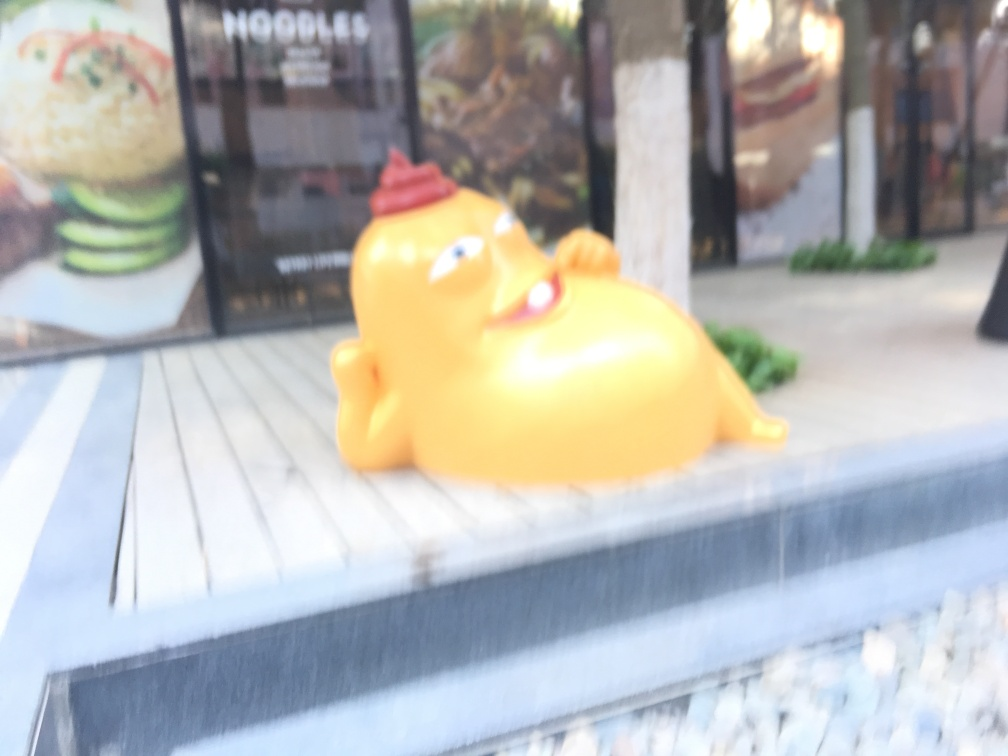How is the texture of the image?
A. Blurry.
B. Smooth.
C. Sharp. The texture of the image can be described as blurry, which is evident from the lack of clear edges and details throughout the photo, particularly in the depiction of the yellow figurine and the surrounding environment. This could be due to a shallow depth of field or camera movement during the exposure. 